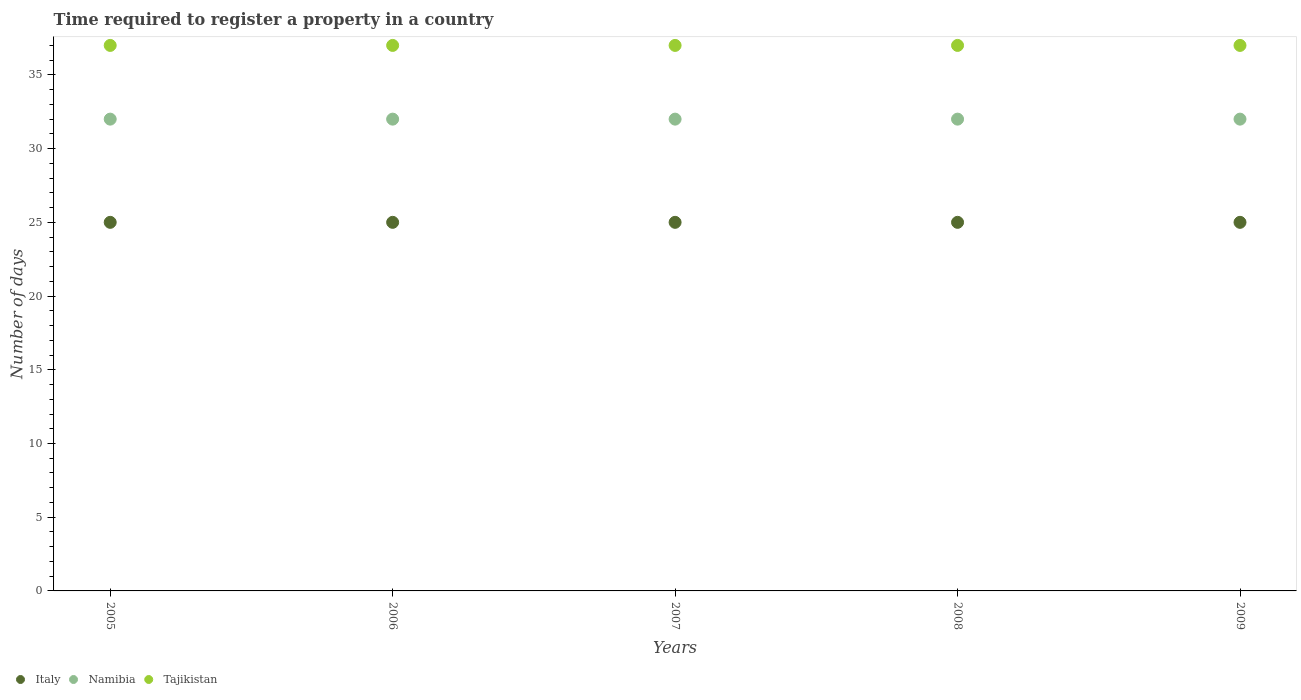Is the number of dotlines equal to the number of legend labels?
Provide a short and direct response. Yes. What is the number of days required to register a property in Namibia in 2005?
Provide a succinct answer. 32. Across all years, what is the maximum number of days required to register a property in Italy?
Your response must be concise. 25. Across all years, what is the minimum number of days required to register a property in Italy?
Keep it short and to the point. 25. In which year was the number of days required to register a property in Italy minimum?
Your answer should be compact. 2005. What is the total number of days required to register a property in Tajikistan in the graph?
Give a very brief answer. 185. What is the difference between the number of days required to register a property in Italy in 2006 and that in 2008?
Offer a very short reply. 0. What is the average number of days required to register a property in Namibia per year?
Provide a succinct answer. 32. In the year 2009, what is the difference between the number of days required to register a property in Italy and number of days required to register a property in Namibia?
Give a very brief answer. -7. In how many years, is the number of days required to register a property in Tajikistan greater than 18 days?
Your answer should be very brief. 5. In how many years, is the number of days required to register a property in Italy greater than the average number of days required to register a property in Italy taken over all years?
Offer a terse response. 0. Is the number of days required to register a property in Tajikistan strictly greater than the number of days required to register a property in Namibia over the years?
Ensure brevity in your answer.  Yes. Is the number of days required to register a property in Italy strictly less than the number of days required to register a property in Tajikistan over the years?
Keep it short and to the point. Yes. How many years are there in the graph?
Make the answer very short. 5. What is the difference between two consecutive major ticks on the Y-axis?
Give a very brief answer. 5. Does the graph contain any zero values?
Offer a very short reply. No. Does the graph contain grids?
Provide a succinct answer. No. What is the title of the graph?
Provide a succinct answer. Time required to register a property in a country. Does "United Kingdom" appear as one of the legend labels in the graph?
Keep it short and to the point. No. What is the label or title of the X-axis?
Your response must be concise. Years. What is the label or title of the Y-axis?
Your answer should be compact. Number of days. What is the Number of days in Italy in 2005?
Make the answer very short. 25. What is the Number of days in Namibia in 2005?
Your response must be concise. 32. What is the Number of days in Tajikistan in 2005?
Your answer should be compact. 37. What is the Number of days in Italy in 2007?
Give a very brief answer. 25. What is the Number of days in Tajikistan in 2007?
Offer a very short reply. 37. What is the Number of days in Italy in 2008?
Provide a short and direct response. 25. What is the Number of days in Namibia in 2008?
Your response must be concise. 32. What is the Number of days in Tajikistan in 2008?
Your answer should be compact. 37. Across all years, what is the maximum Number of days of Tajikistan?
Make the answer very short. 37. Across all years, what is the minimum Number of days in Namibia?
Provide a succinct answer. 32. Across all years, what is the minimum Number of days of Tajikistan?
Keep it short and to the point. 37. What is the total Number of days of Italy in the graph?
Your answer should be compact. 125. What is the total Number of days in Namibia in the graph?
Offer a terse response. 160. What is the total Number of days of Tajikistan in the graph?
Your response must be concise. 185. What is the difference between the Number of days in Italy in 2005 and that in 2006?
Give a very brief answer. 0. What is the difference between the Number of days in Tajikistan in 2005 and that in 2006?
Provide a succinct answer. 0. What is the difference between the Number of days of Italy in 2005 and that in 2007?
Your answer should be compact. 0. What is the difference between the Number of days of Namibia in 2005 and that in 2007?
Provide a succinct answer. 0. What is the difference between the Number of days in Italy in 2005 and that in 2009?
Your response must be concise. 0. What is the difference between the Number of days of Tajikistan in 2005 and that in 2009?
Your answer should be compact. 0. What is the difference between the Number of days of Italy in 2006 and that in 2007?
Make the answer very short. 0. What is the difference between the Number of days of Namibia in 2006 and that in 2007?
Keep it short and to the point. 0. What is the difference between the Number of days of Tajikistan in 2006 and that in 2007?
Keep it short and to the point. 0. What is the difference between the Number of days in Italy in 2006 and that in 2008?
Keep it short and to the point. 0. What is the difference between the Number of days of Namibia in 2006 and that in 2008?
Ensure brevity in your answer.  0. What is the difference between the Number of days of Italy in 2007 and that in 2008?
Your answer should be very brief. 0. What is the difference between the Number of days in Namibia in 2007 and that in 2009?
Provide a succinct answer. 0. What is the difference between the Number of days in Tajikistan in 2007 and that in 2009?
Your answer should be very brief. 0. What is the difference between the Number of days in Italy in 2008 and that in 2009?
Your answer should be compact. 0. What is the difference between the Number of days of Namibia in 2008 and that in 2009?
Your response must be concise. 0. What is the difference between the Number of days in Italy in 2005 and the Number of days in Tajikistan in 2006?
Provide a succinct answer. -12. What is the difference between the Number of days of Italy in 2005 and the Number of days of Namibia in 2007?
Keep it short and to the point. -7. What is the difference between the Number of days of Italy in 2005 and the Number of days of Tajikistan in 2007?
Provide a short and direct response. -12. What is the difference between the Number of days of Namibia in 2005 and the Number of days of Tajikistan in 2007?
Give a very brief answer. -5. What is the difference between the Number of days of Italy in 2005 and the Number of days of Tajikistan in 2009?
Your response must be concise. -12. What is the difference between the Number of days of Italy in 2006 and the Number of days of Namibia in 2007?
Make the answer very short. -7. What is the difference between the Number of days of Italy in 2006 and the Number of days of Tajikistan in 2007?
Ensure brevity in your answer.  -12. What is the difference between the Number of days in Italy in 2006 and the Number of days in Namibia in 2009?
Your answer should be very brief. -7. What is the difference between the Number of days in Italy in 2007 and the Number of days in Namibia in 2008?
Keep it short and to the point. -7. What is the difference between the Number of days in Italy in 2007 and the Number of days in Tajikistan in 2008?
Your answer should be compact. -12. What is the difference between the Number of days of Namibia in 2007 and the Number of days of Tajikistan in 2008?
Give a very brief answer. -5. What is the difference between the Number of days of Italy in 2007 and the Number of days of Namibia in 2009?
Give a very brief answer. -7. What is the difference between the Number of days in Italy in 2008 and the Number of days in Namibia in 2009?
Your answer should be very brief. -7. What is the difference between the Number of days in Italy in 2008 and the Number of days in Tajikistan in 2009?
Offer a very short reply. -12. What is the difference between the Number of days in Namibia in 2008 and the Number of days in Tajikistan in 2009?
Provide a short and direct response. -5. What is the average Number of days in Italy per year?
Keep it short and to the point. 25. What is the average Number of days of Namibia per year?
Provide a short and direct response. 32. What is the average Number of days in Tajikistan per year?
Make the answer very short. 37. In the year 2005, what is the difference between the Number of days of Italy and Number of days of Namibia?
Your answer should be very brief. -7. In the year 2005, what is the difference between the Number of days in Namibia and Number of days in Tajikistan?
Make the answer very short. -5. In the year 2006, what is the difference between the Number of days of Italy and Number of days of Namibia?
Ensure brevity in your answer.  -7. In the year 2006, what is the difference between the Number of days in Italy and Number of days in Tajikistan?
Your answer should be very brief. -12. In the year 2006, what is the difference between the Number of days in Namibia and Number of days in Tajikistan?
Your answer should be compact. -5. In the year 2008, what is the difference between the Number of days in Italy and Number of days in Namibia?
Your answer should be very brief. -7. In the year 2008, what is the difference between the Number of days in Italy and Number of days in Tajikistan?
Make the answer very short. -12. In the year 2008, what is the difference between the Number of days of Namibia and Number of days of Tajikistan?
Provide a short and direct response. -5. What is the ratio of the Number of days in Italy in 2005 to that in 2006?
Your answer should be very brief. 1. What is the ratio of the Number of days in Namibia in 2005 to that in 2006?
Make the answer very short. 1. What is the ratio of the Number of days in Tajikistan in 2005 to that in 2006?
Offer a terse response. 1. What is the ratio of the Number of days of Italy in 2005 to that in 2007?
Give a very brief answer. 1. What is the ratio of the Number of days in Tajikistan in 2005 to that in 2008?
Keep it short and to the point. 1. What is the ratio of the Number of days of Namibia in 2005 to that in 2009?
Provide a short and direct response. 1. What is the ratio of the Number of days of Tajikistan in 2005 to that in 2009?
Ensure brevity in your answer.  1. What is the ratio of the Number of days in Italy in 2006 to that in 2007?
Your response must be concise. 1. What is the ratio of the Number of days in Namibia in 2006 to that in 2008?
Your answer should be compact. 1. What is the ratio of the Number of days of Italy in 2006 to that in 2009?
Ensure brevity in your answer.  1. What is the ratio of the Number of days of Tajikistan in 2006 to that in 2009?
Offer a very short reply. 1. What is the ratio of the Number of days in Namibia in 2007 to that in 2008?
Make the answer very short. 1. What is the ratio of the Number of days of Tajikistan in 2007 to that in 2008?
Your answer should be compact. 1. What is the ratio of the Number of days of Italy in 2007 to that in 2009?
Make the answer very short. 1. What is the ratio of the Number of days of Namibia in 2007 to that in 2009?
Make the answer very short. 1. What is the ratio of the Number of days of Tajikistan in 2007 to that in 2009?
Keep it short and to the point. 1. What is the ratio of the Number of days in Namibia in 2008 to that in 2009?
Offer a terse response. 1. What is the ratio of the Number of days in Tajikistan in 2008 to that in 2009?
Provide a succinct answer. 1. What is the difference between the highest and the second highest Number of days of Namibia?
Keep it short and to the point. 0. What is the difference between the highest and the lowest Number of days in Italy?
Your answer should be very brief. 0. What is the difference between the highest and the lowest Number of days of Namibia?
Your response must be concise. 0. 